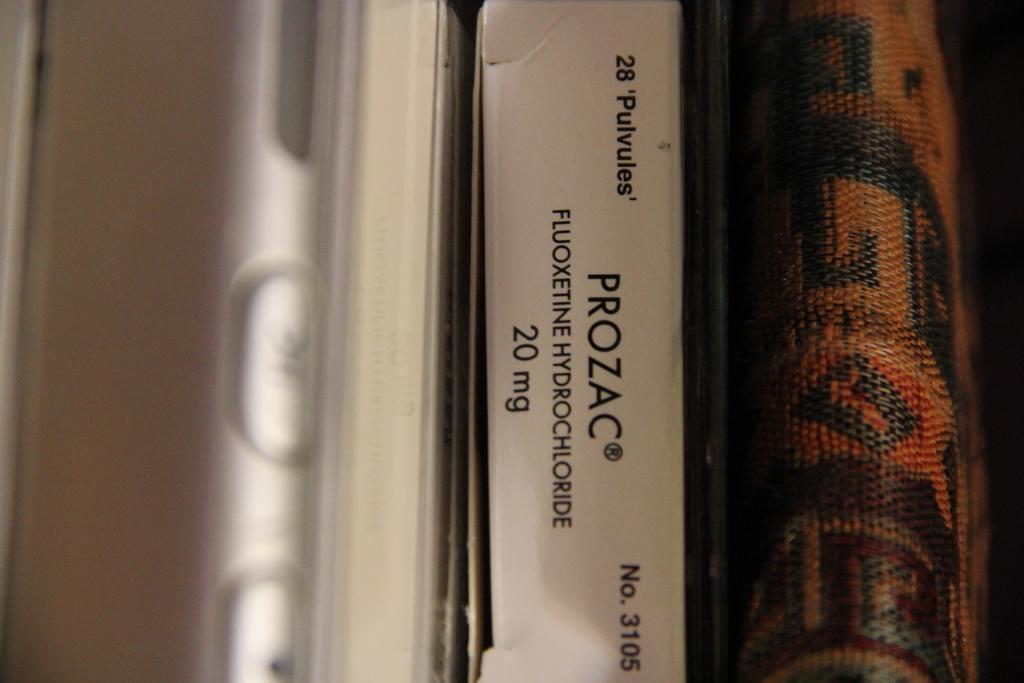<image>
Relay a brief, clear account of the picture shown. Packaging for a prescription that reads PROZAC fluoxetine hydrochloride. 